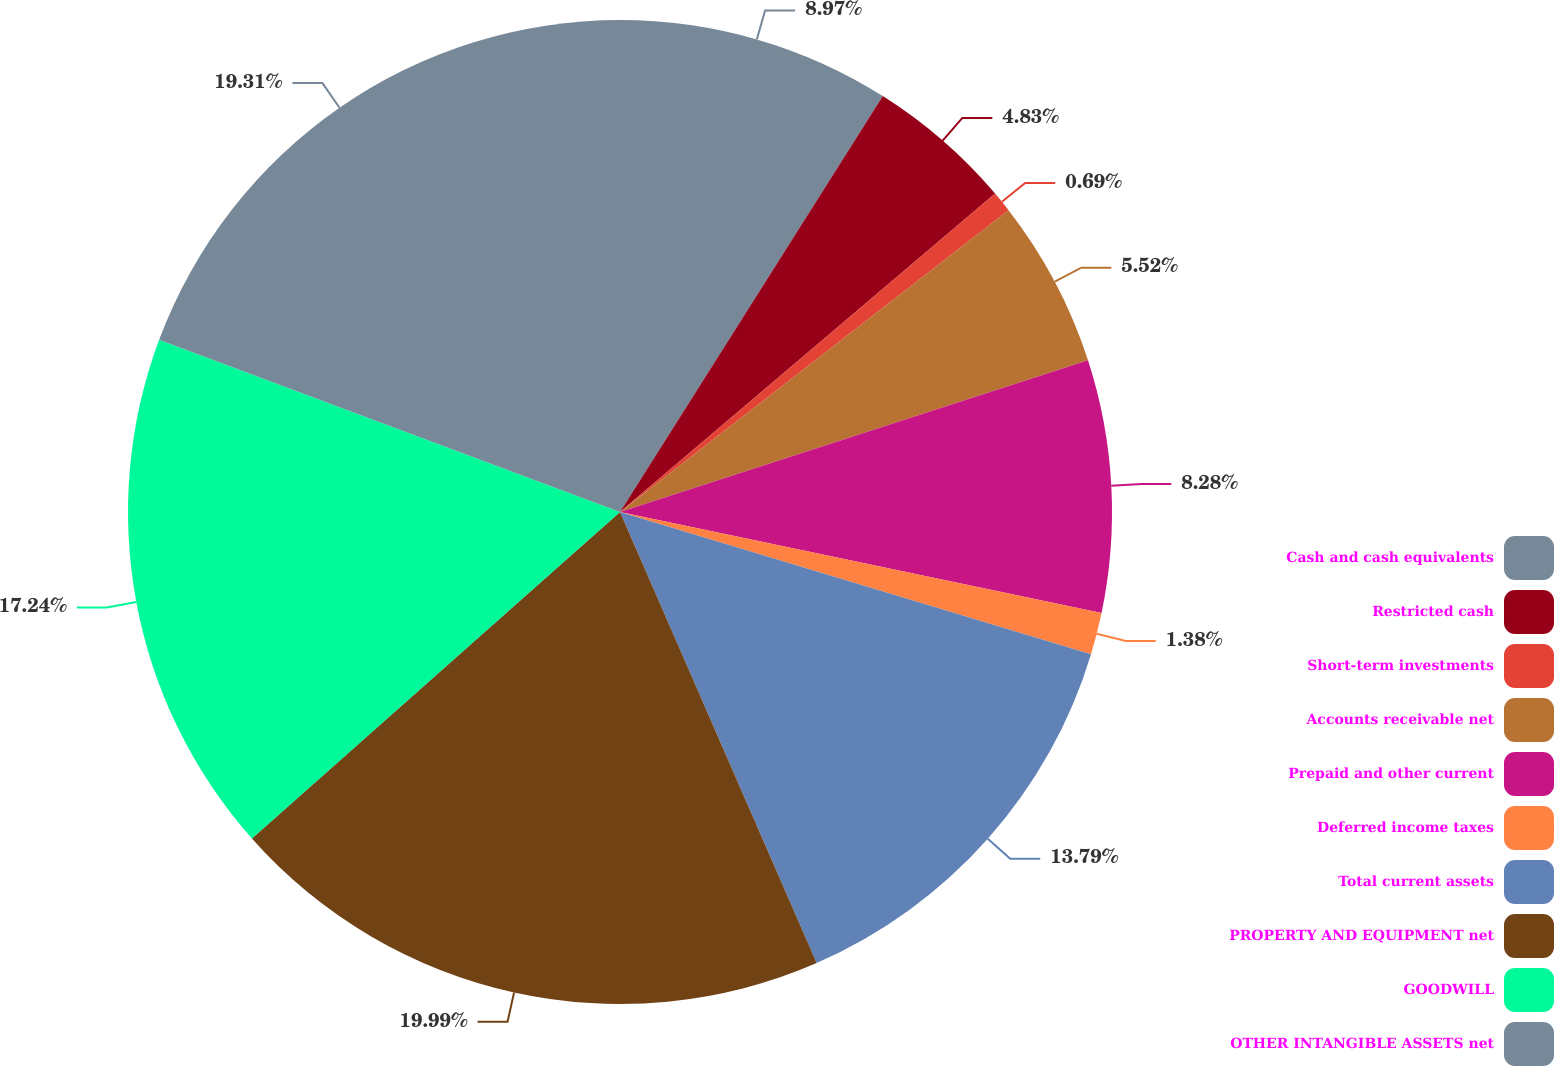<chart> <loc_0><loc_0><loc_500><loc_500><pie_chart><fcel>Cash and cash equivalents<fcel>Restricted cash<fcel>Short-term investments<fcel>Accounts receivable net<fcel>Prepaid and other current<fcel>Deferred income taxes<fcel>Total current assets<fcel>PROPERTY AND EQUIPMENT net<fcel>GOODWILL<fcel>OTHER INTANGIBLE ASSETS net<nl><fcel>8.97%<fcel>4.83%<fcel>0.69%<fcel>5.52%<fcel>8.28%<fcel>1.38%<fcel>13.79%<fcel>20.0%<fcel>17.24%<fcel>19.31%<nl></chart> 